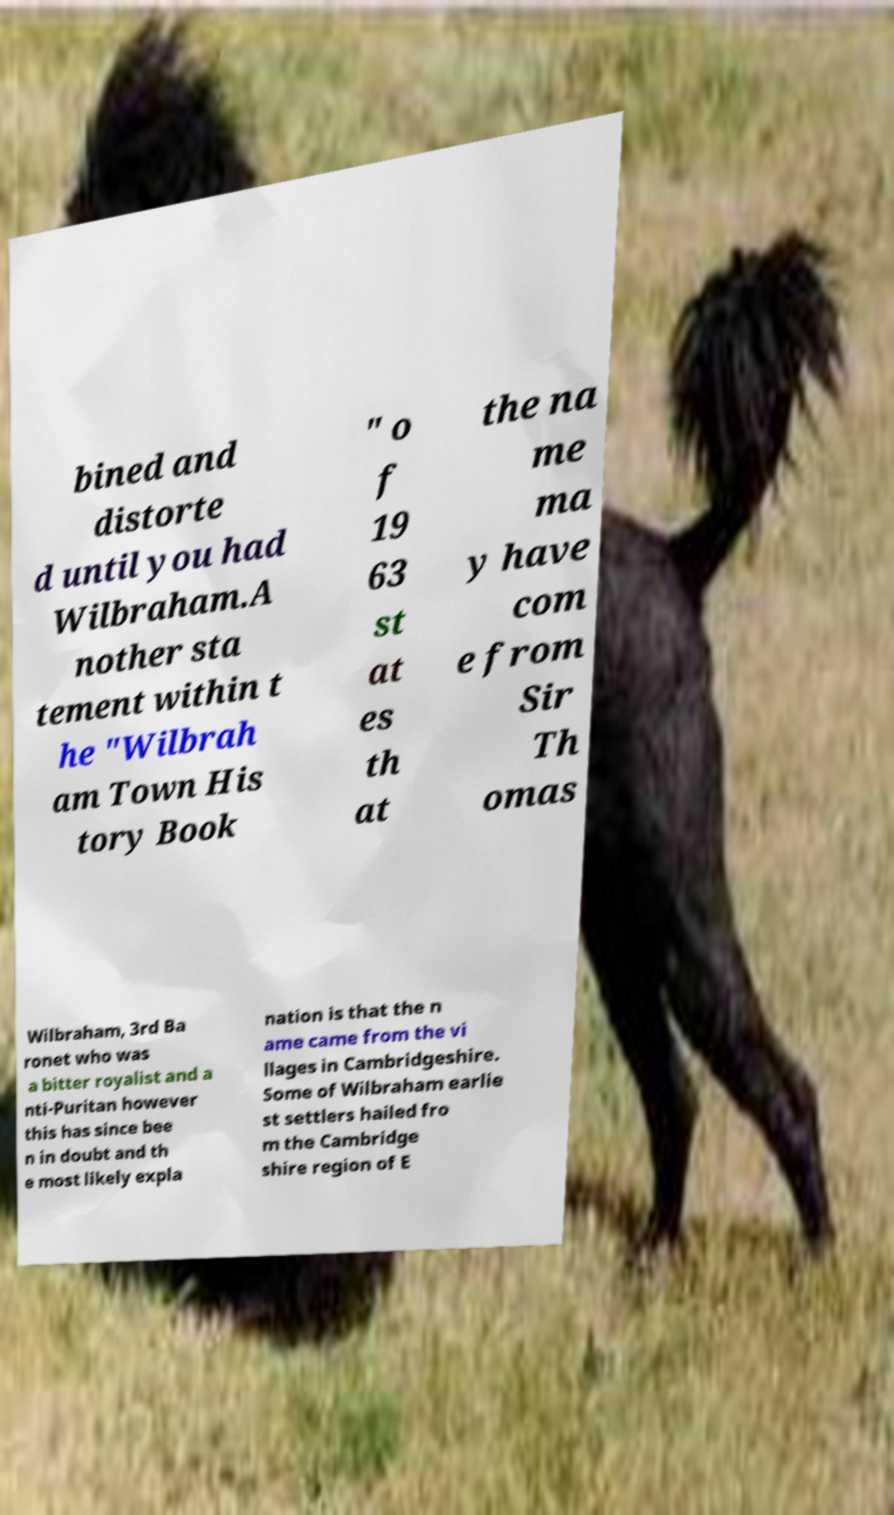Can you accurately transcribe the text from the provided image for me? bined and distorte d until you had Wilbraham.A nother sta tement within t he "Wilbrah am Town His tory Book " o f 19 63 st at es th at the na me ma y have com e from Sir Th omas Wilbraham, 3rd Ba ronet who was a bitter royalist and a nti-Puritan however this has since bee n in doubt and th e most likely expla nation is that the n ame came from the vi llages in Cambridgeshire. Some of Wilbraham earlie st settlers hailed fro m the Cambridge shire region of E 